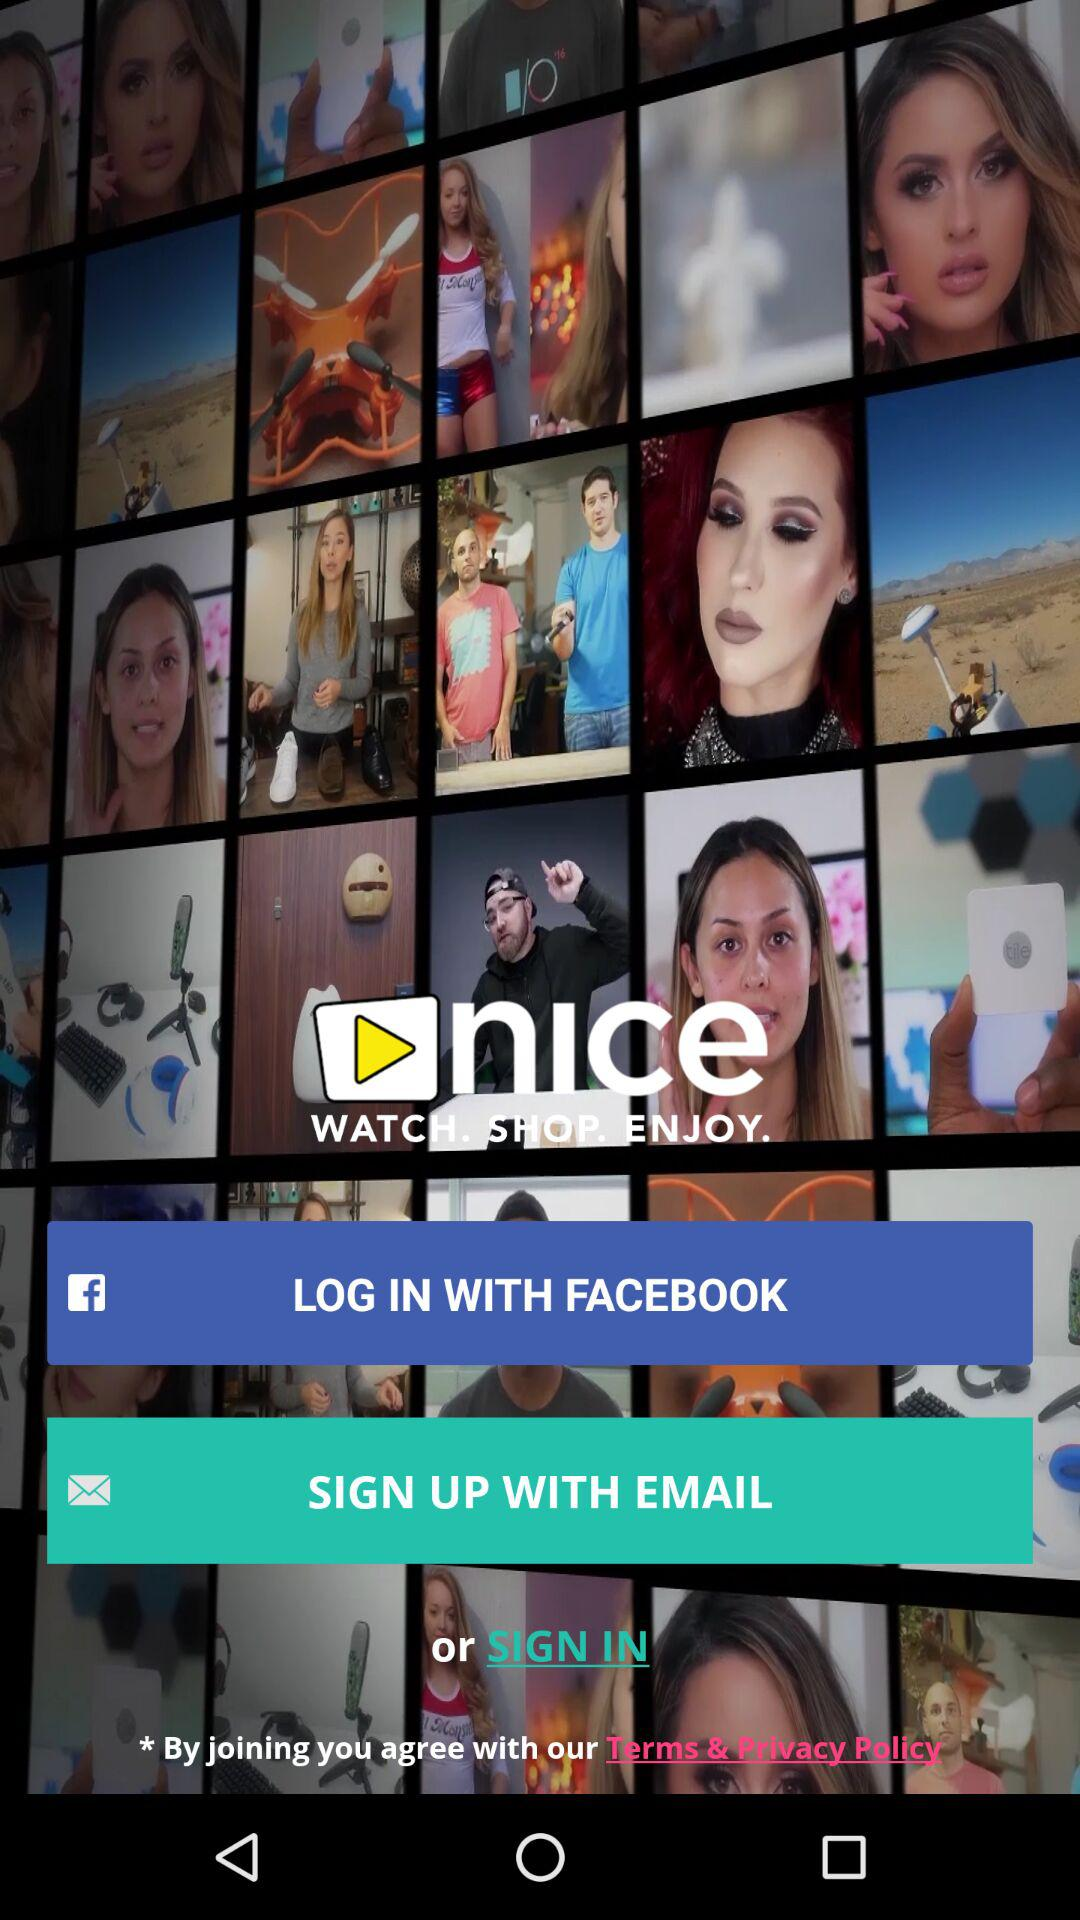What other applications can be used to log in to the profile? The applications are Facebook and email. 